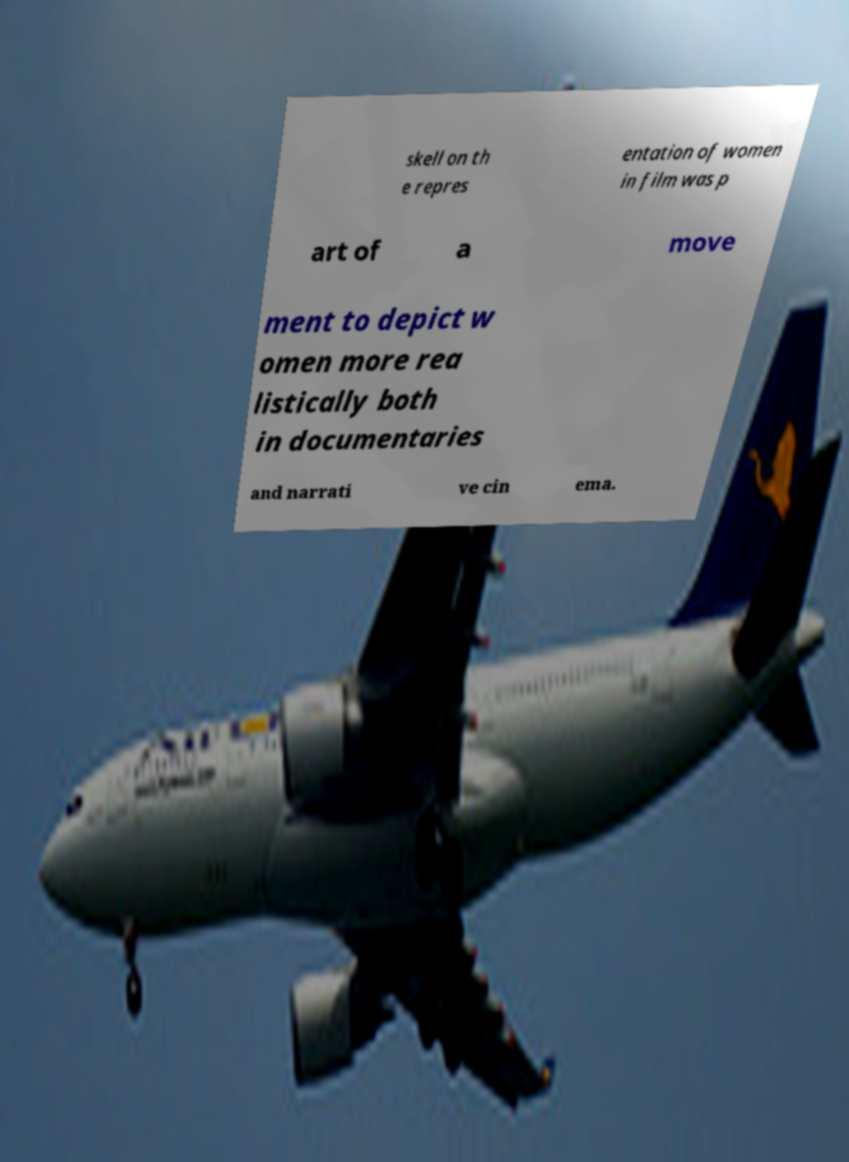For documentation purposes, I need the text within this image transcribed. Could you provide that? skell on th e repres entation of women in film was p art of a move ment to depict w omen more rea listically both in documentaries and narrati ve cin ema. 